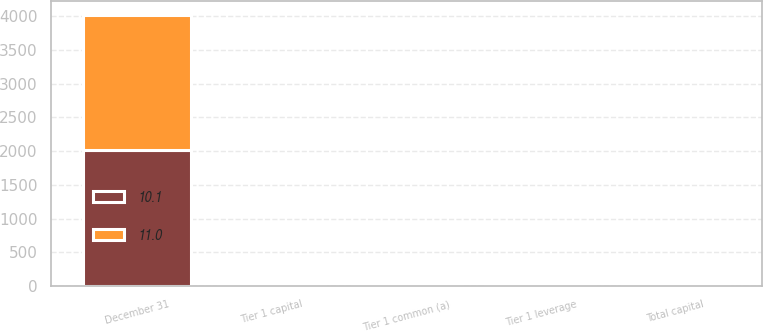Convert chart. <chart><loc_0><loc_0><loc_500><loc_500><stacked_bar_chart><ecel><fcel>December 31<fcel>Tier 1 capital<fcel>Total capital<fcel>Tier 1 leverage<fcel>Tier 1 common (a)<nl><fcel>10.1<fcel>2012<fcel>12.6<fcel>15.3<fcel>7.1<fcel>11<nl><fcel>11<fcel>2011<fcel>12.3<fcel>15.4<fcel>6.8<fcel>10.1<nl></chart> 